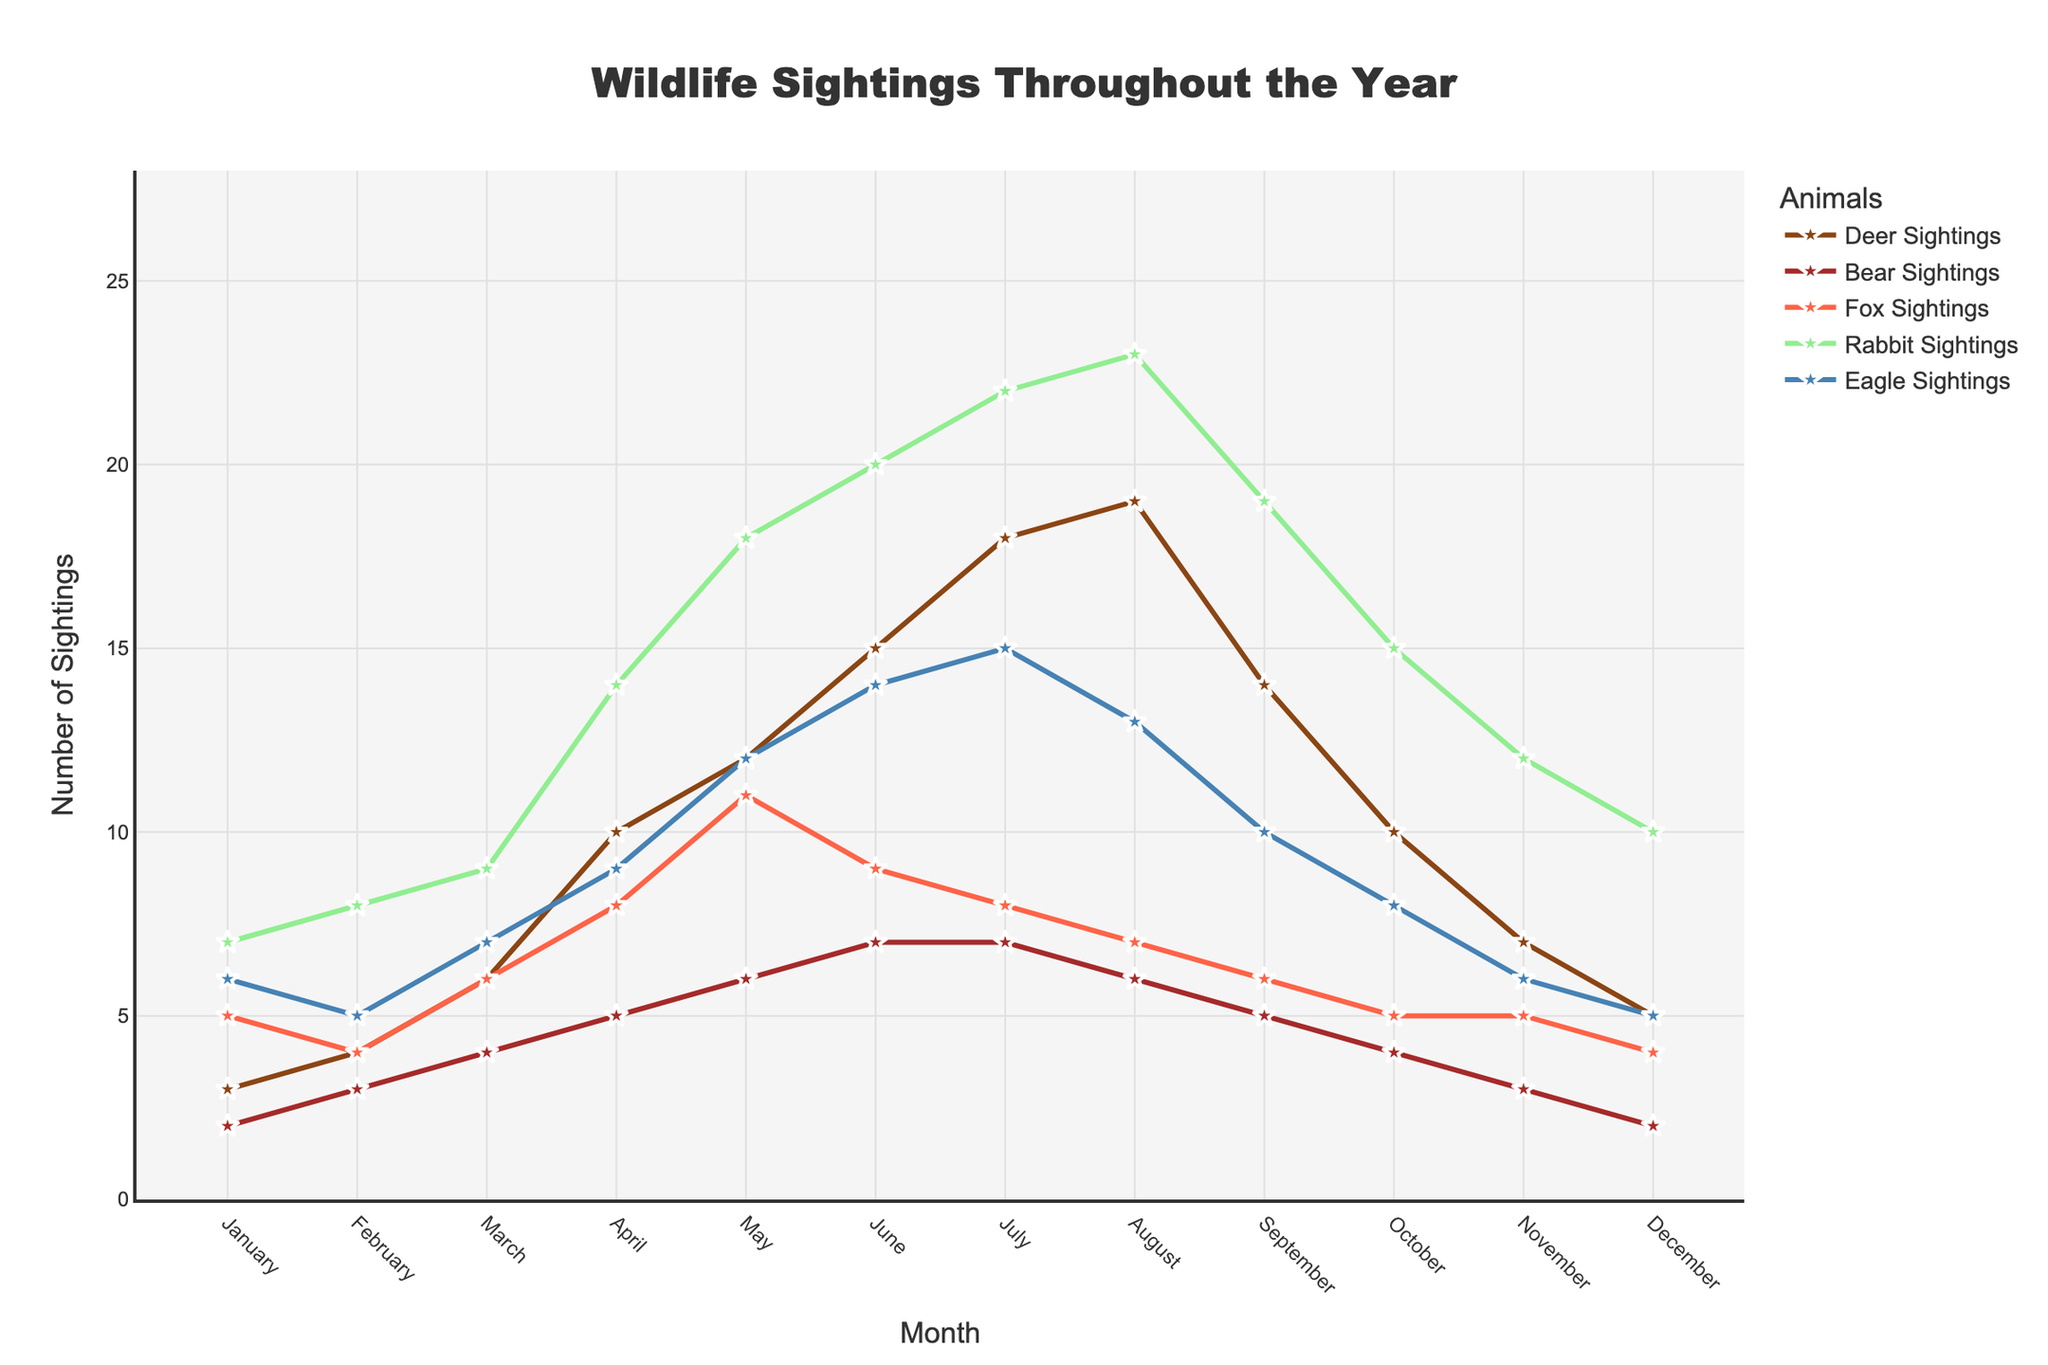What is the title of the plot? The title of the plot is usually at the top and summarizes its main subject. In this case, it reads 'Wildlife Sightings Throughout the Year'.
Answer: Wildlife Sightings Throughout the Year How many bear sightings were recorded in March? Look for the line corresponding to bear sightings and locate the data point for March. The y-axis tells us that it is 4.
Answer: 4 Which animal had the highest number of sightings in June? Compare the data points for all animals in June. The highest point is the rabbit sightings line, which is at 20.
Answer: Rabbit What is the total number of sightings for eagles in the first quarter (January, February, March)? Sum the values of eagle sightings for January (6), February (5), and March (7). The total is 6 + 5 + 7 = 18.
Answer: 18 During which month were fox sightings the lowest? Check the line for fox sightings and find the lowest point, which is noted in August and October at 4.
Answer: October Between July and December, in which month did deer sightings decrease the most? Look at the points for deer sightings from July to December. Find the month-to-month differences and identify the greatest decrease, which occurs from August (19) to September (14), a drop of 5.
Answer: August to September How does the pattern of deer sightings compare to bear sightings throughout the year? Compare the trends for deer and bear lines. Deer sightings show a steady increase, peaking in July, while bear sightings increase slowly and peak in June and July at a lower number.
Answer: Deer sightings increase more sharply and reach a higher peak What is the average number of sightings for foxes between April and June? Add the fox sightings numbers for April (8), May (11), and June (9), then divide by 3. The average is (8 + 11 + 9) / 3 = 9.33.
Answer: 9.33 In which month does the number of rabbit sightings first exceed 15? Follow the rabbit sightings line and find the first point above 15 which occurs in April at 18.
Answer: April 